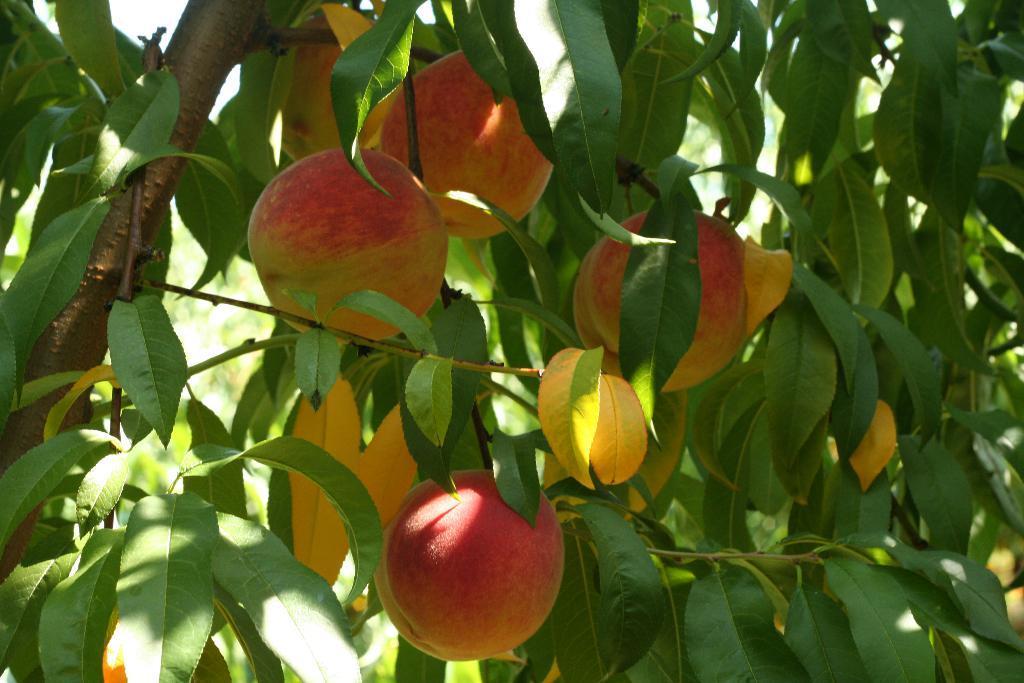Can you describe this image briefly? In the image there is a stem with leaves. And also there are fruits. 